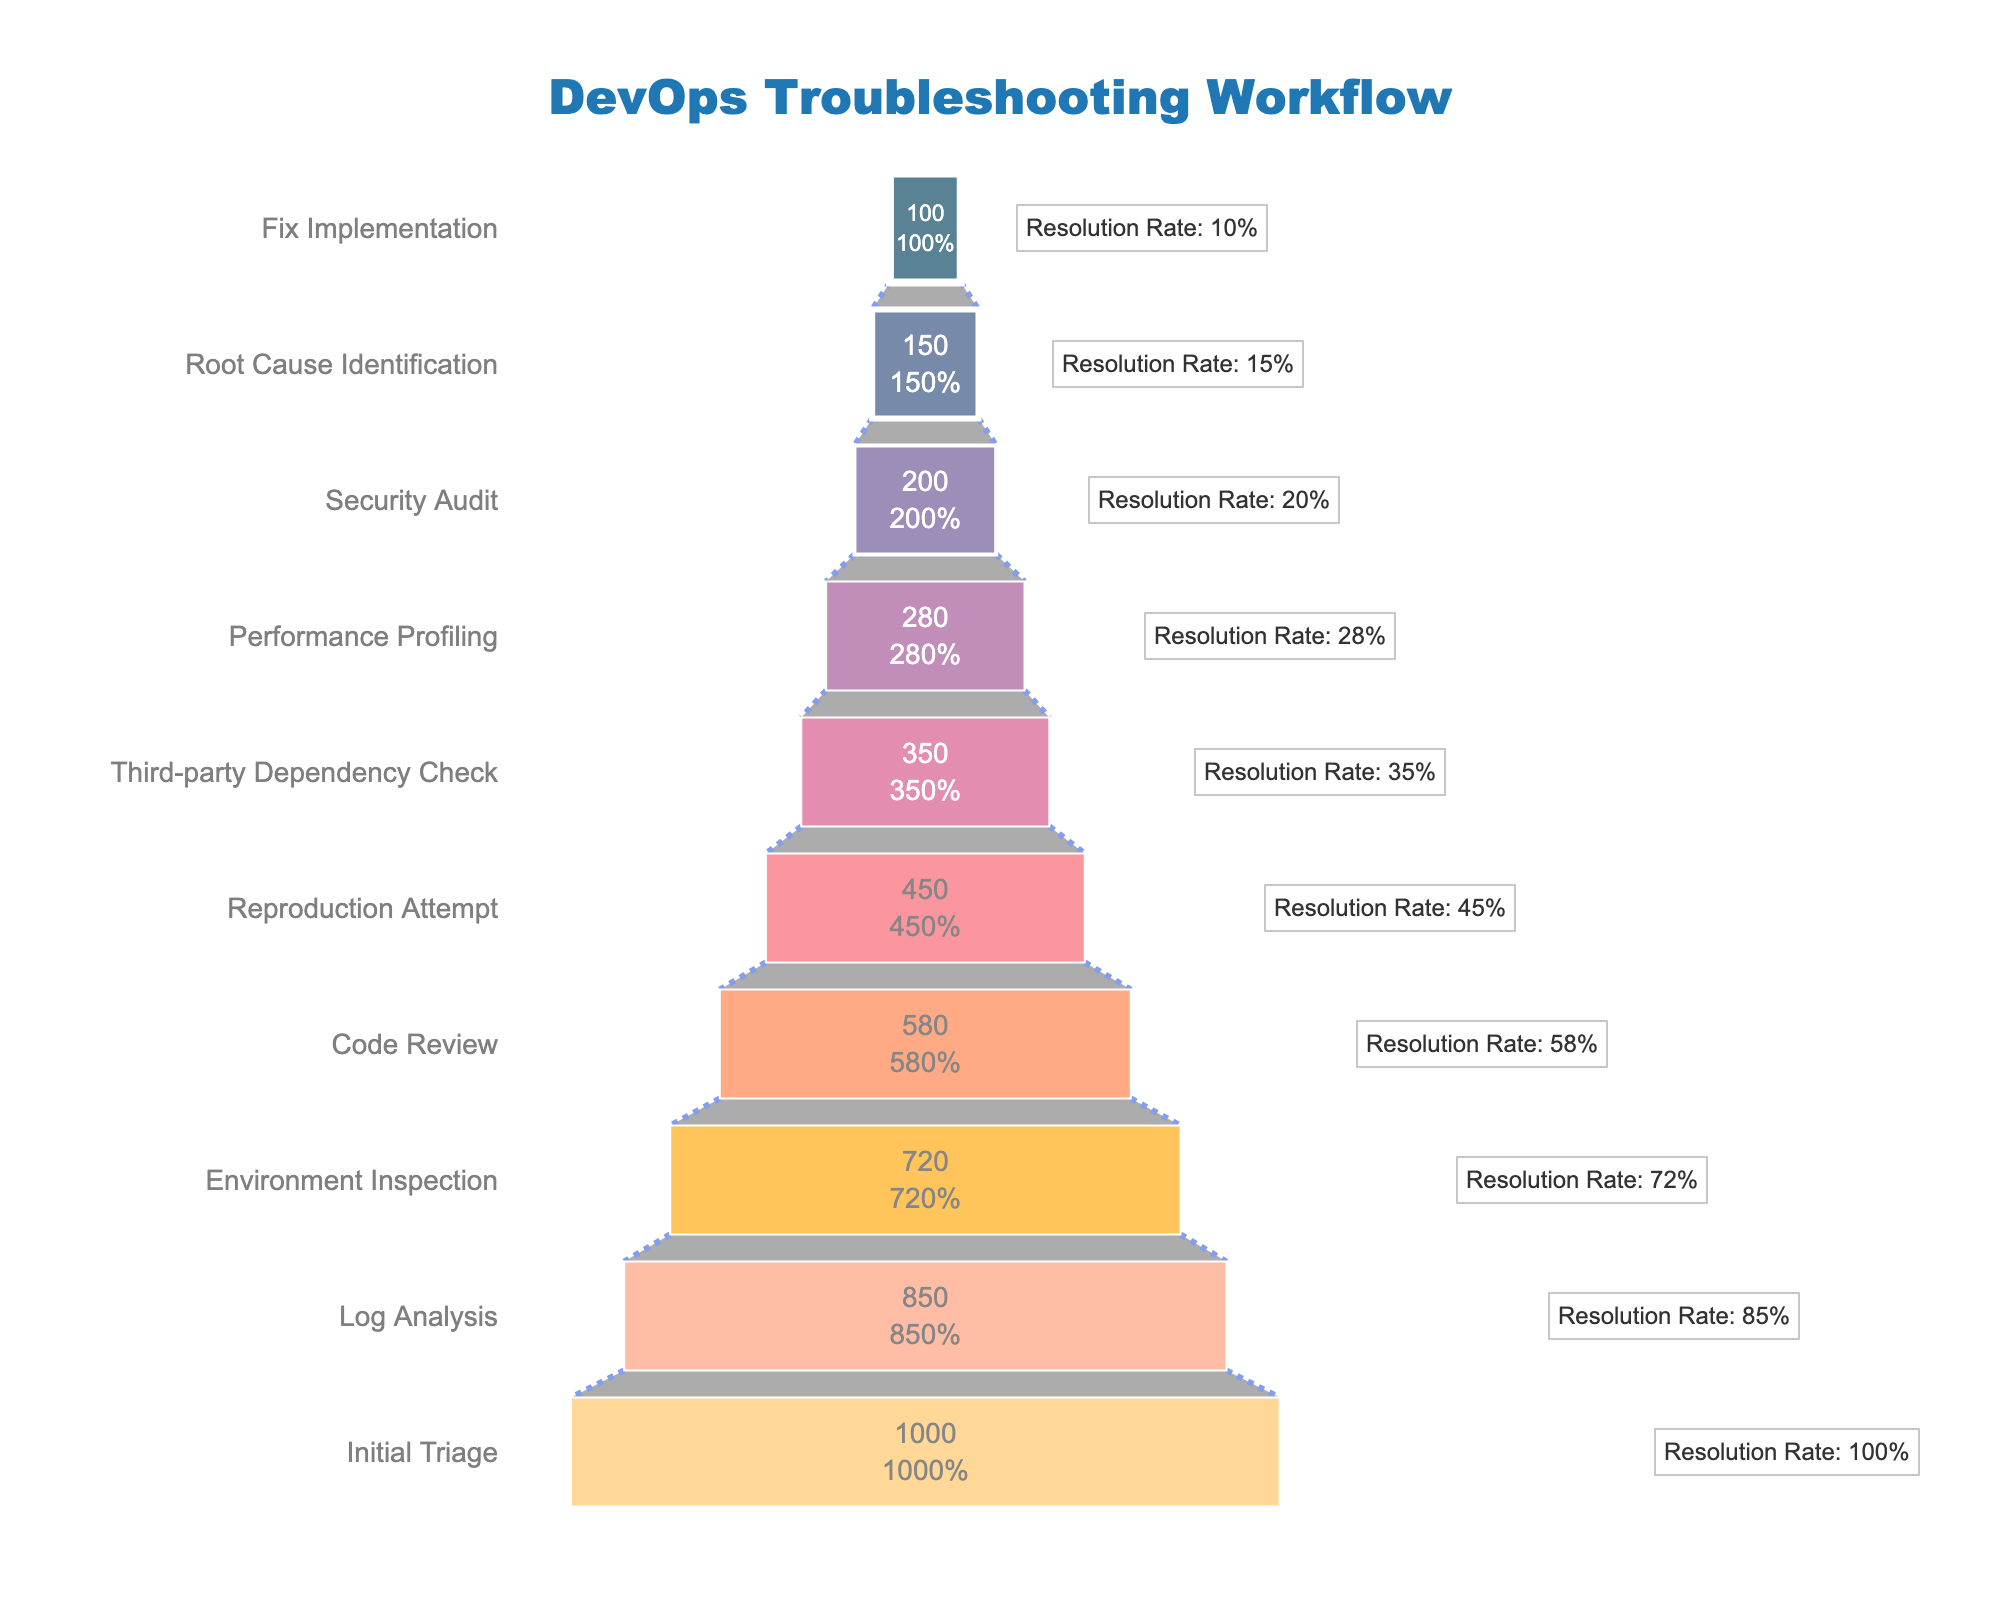What is the total number of issues at the Initial Triage stage? The number of issues is directly shown in the figure next to the "Initial Triage" stage.
Answer: 1000 At which stage does the biggest drop in the number of issues occur? By examining the differences between consecutive stages, the largest drop occurs between "Initial Triage" and "Log Analysis" stages.
Answer: Log Analysis What is the resolution rate at the Fix Implementation stage? The figure shows an annotation next to "Fix Implementation" indicating its resolution rate.
Answer: 10% Which stage has the lowest resolution rate, and what is that rate? By comparing the resolution rate annotations, the lowest rate is found at the "Fix Implementation" stage.
Answer: Fix Implementation, 10% What is the total number of issues addressed from the Initial Triage to the Root Cause Identification stages combined? Sum the number of issues from the "Initial Triage" stage down to the "Root Cause Identification" stage (1000 + 850 + 720 + 580 + 450 + 350 + 280 + 200 + 150).
Answer: 4580 How many stages have resolution rates less than 30%? Count the stages with resolution rates shown in the annotations that are under 30%: "Performance Profiling", "Security Audit", "Root Cause Identification", and "Fix Implementation".
Answer: 4 Is the number of issues at the Log Analysis stage greater than the combined total at the Security Audit and Root Cause Identification stages? Compare the number of issues at "Log Analysis" (850) with the sum of issues at "Security Audit" (200) and "Root Cause Identification" (150), which in total is 350.
Answer: Yes What is the average resolution rate across all stages? Add up all the resolution rates and divide by the number of stages: (100 + 85 + 72 + 58 + 45 + 35 + 28 + 20 + 15 + 10) / 10 = 46.8%.
Answer: 46.8% Which stage shows a resolution rate closest to the average resolution rate? Calculate and compare each stage's resolution rate to the average resolution rate (46.8%). "Reproduction Attempt" at 45% is the closest.
Answer: Reproduction Attempt How many stages experience a drop of more than 100 issues between consecutive steps? Calculate the differences between consecutive stages and count those with a decrease of more than 100: from "Initial Triage" (150), "Log Analysis" (130), "Code Review" (130).
Answer: 3 